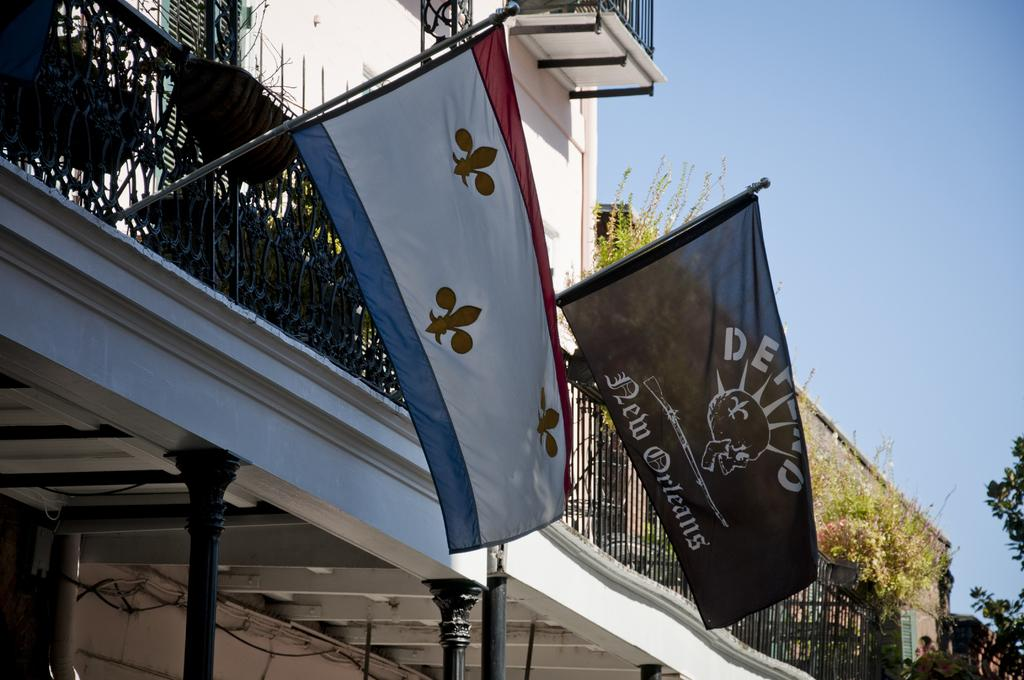What can be seen in the foreground of the image? In the foreground of the image, there are two flags, a railing, flower pots, pillars, and plants. Where are the flags attached? The flags are attached to a building. What is visible in the top right corner of the image? The sky is visible in the top right corner of the image. How many feet are visible in the image? There are no feet visible in the image. Is there a birthday celebration happening in the image? There is no indication of a birthday celebration in the image. 